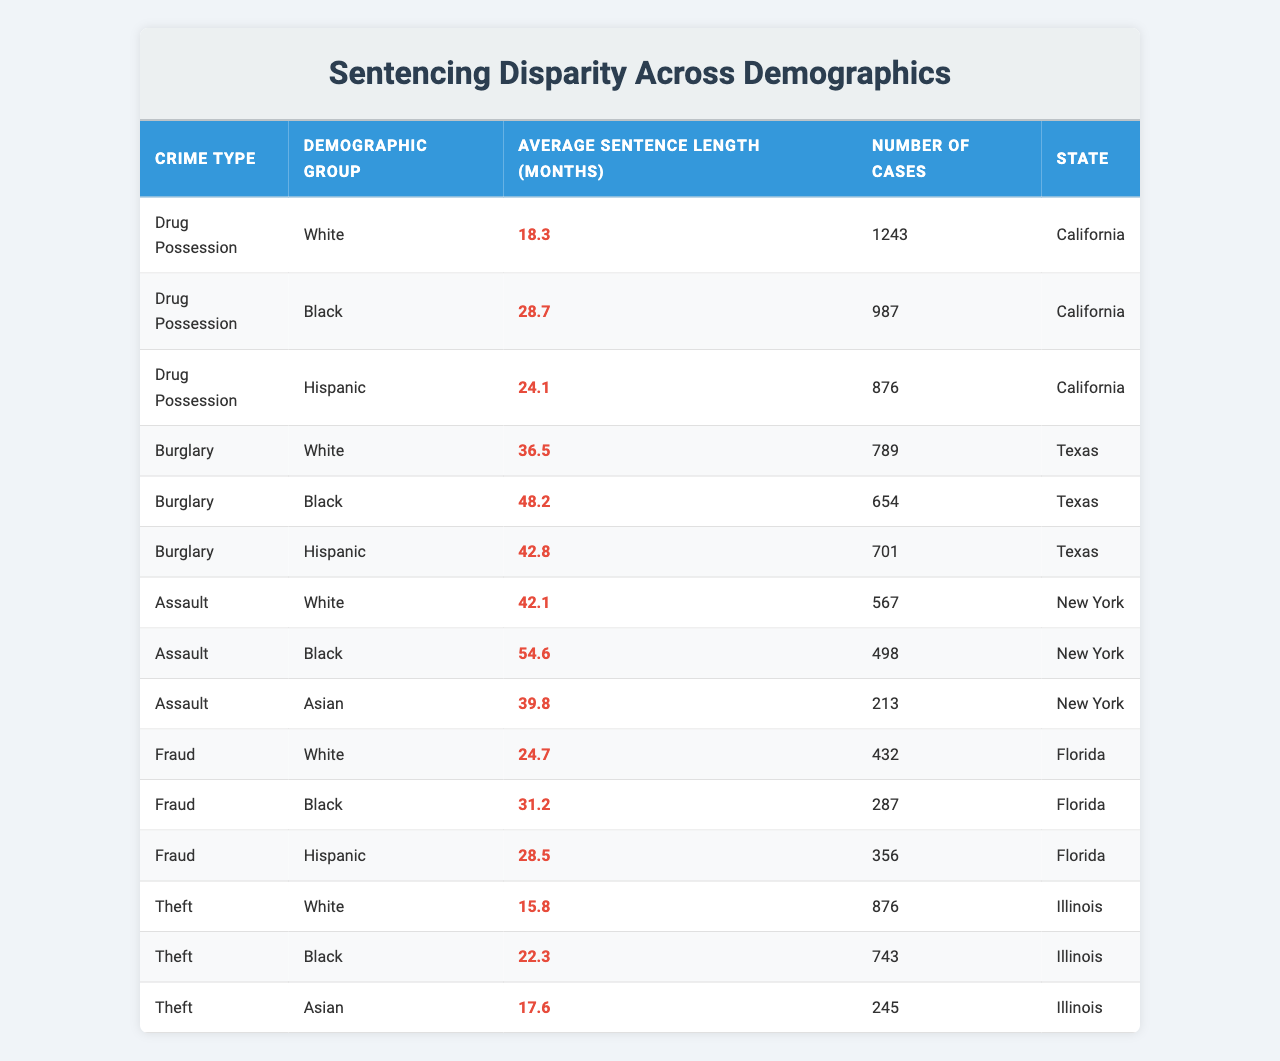What is the average sentence length for drug possession among Black individuals in California? The table shows that for Black individuals charged with drug possession in California, the average sentence length is 28.7 months.
Answer: 28.7 months How does the average sentence length for drug possession compare between White and Black individuals in California? The average sentence length for White individuals is 18.3 months, while for Black individuals it is 28.7 months. The difference is 28.7 - 18.3 = 10.4 months longer for Black individuals.
Answer: 10.4 months longer Which crime type has the longest average sentence length for Hispanic individuals, and what is that length? The data indicates that for Hispanic individuals, the longest average sentence length is for the crime of burglary, which is 42.8 months.
Answer: 42.8 months Is the average sentence length for Black individuals accused of assault greater than that for White individuals accused of the same crime? Yes, the average sentence length for Black individuals accused of assault is 54.6 months, while for White individuals it is 42.1 months.
Answer: Yes What is the overall average sentence length for all crimes for White individuals? To find this, we sum the average sentences for White individuals across all listed crimes: (18.3 + 36.5 + 42.1 + 24.7 + 15.8) = 137.4 months. Then we divide by the number of crimes (5), so 137.4 / 5 = 27.48 months.
Answer: 27.48 months Which demographic group has the highest average sentence length for burglary, and what is that length? The table shows that for burglary, Black individuals have the highest average sentence length of 48.2 months compared to White and Hispanic individuals.
Answer: Black individuals, 48.2 months Is the average sentence length for theft longer for Black individuals than for Asian individuals in Illinois? Yes, for theft in Illinois, Black individuals have an average sentence length of 22.3 months, while Asian individuals have 17.6 months, showing that Black individuals have a longer sentence.
Answer: Yes What is the difference in average sentence length between Black and Hispanic individuals for fraud cases in Florida? For fraud cases, Black individuals have an average sentence length of 31.2 months, while Hispanic individuals have 28.5 months. The difference is 31.2 - 28.5 = 2.7 months longer for Black individuals.
Answer: 2.7 months longer Which crime has the lowest average sentence length among the demographic groups in the table? The crime with the lowest average sentence length is theft among White individuals, with an average of 15.8 months.
Answer: Theft, 15.8 months What is the average sentence length for Asian individuals accused of assault in New York compared to that for White individuals? The average sentence length for Asian individuals is 39.8 months, while for White individuals it is 42.1 months. Thus, White individuals have a longer average sentence length by 42.1 - 39.8 = 2.3 months.
Answer: 2.3 months longer for White individuals 